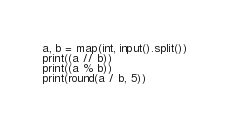<code> <loc_0><loc_0><loc_500><loc_500><_Python_>a, b = map(int, input().split())
print((a // b))
print((a % b))
print(round(a / b, 5))

</code> 